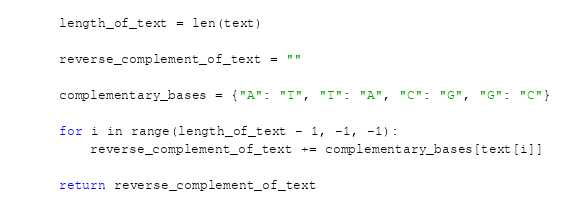Convert code to text. <code><loc_0><loc_0><loc_500><loc_500><_Python_>
    length_of_text = len(text)

    reverse_complement_of_text = ""

    complementary_bases = {"A": "T", "T": "A", "C": "G", "G": "C"}

    for i in range(length_of_text - 1, -1, -1):
        reverse_complement_of_text += complementary_bases[text[i]]

    return reverse_complement_of_text
</code> 